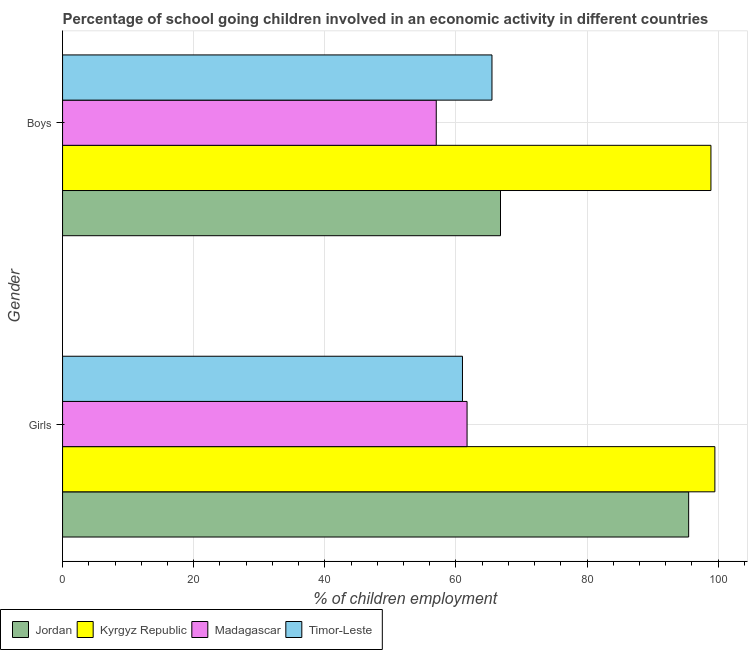Are the number of bars on each tick of the Y-axis equal?
Your answer should be compact. Yes. How many bars are there on the 1st tick from the top?
Ensure brevity in your answer.  4. How many bars are there on the 2nd tick from the bottom?
Your response must be concise. 4. What is the label of the 2nd group of bars from the top?
Offer a very short reply. Girls. Across all countries, what is the maximum percentage of school going girls?
Make the answer very short. 99.5. Across all countries, what is the minimum percentage of school going girls?
Provide a succinct answer. 61. In which country was the percentage of school going boys maximum?
Provide a succinct answer. Kyrgyz Republic. In which country was the percentage of school going boys minimum?
Make the answer very short. Madagascar. What is the total percentage of school going boys in the graph?
Offer a terse response. 288.2. What is the difference between the percentage of school going girls in Timor-Leste and that in Jordan?
Offer a terse response. -34.5. What is the difference between the percentage of school going boys in Kyrgyz Republic and the percentage of school going girls in Madagascar?
Offer a terse response. 37.2. What is the average percentage of school going boys per country?
Keep it short and to the point. 72.05. What is the difference between the percentage of school going girls and percentage of school going boys in Jordan?
Offer a terse response. 28.7. In how many countries, is the percentage of school going girls greater than 4 %?
Ensure brevity in your answer.  4. What is the ratio of the percentage of school going girls in Madagascar to that in Jordan?
Give a very brief answer. 0.65. Is the percentage of school going boys in Timor-Leste less than that in Jordan?
Provide a short and direct response. Yes. In how many countries, is the percentage of school going girls greater than the average percentage of school going girls taken over all countries?
Provide a short and direct response. 2. What does the 2nd bar from the top in Girls represents?
Provide a succinct answer. Madagascar. What does the 4th bar from the bottom in Boys represents?
Make the answer very short. Timor-Leste. How many bars are there?
Offer a very short reply. 8. Are all the bars in the graph horizontal?
Your answer should be compact. Yes. How many countries are there in the graph?
Your answer should be compact. 4. Are the values on the major ticks of X-axis written in scientific E-notation?
Your response must be concise. No. Does the graph contain any zero values?
Make the answer very short. No. How many legend labels are there?
Offer a terse response. 4. How are the legend labels stacked?
Provide a short and direct response. Horizontal. What is the title of the graph?
Your answer should be very brief. Percentage of school going children involved in an economic activity in different countries. Does "Small states" appear as one of the legend labels in the graph?
Your answer should be compact. No. What is the label or title of the X-axis?
Offer a terse response. % of children employment. What is the label or title of the Y-axis?
Provide a short and direct response. Gender. What is the % of children employment of Jordan in Girls?
Provide a succinct answer. 95.5. What is the % of children employment in Kyrgyz Republic in Girls?
Provide a short and direct response. 99.5. What is the % of children employment in Madagascar in Girls?
Offer a very short reply. 61.7. What is the % of children employment of Timor-Leste in Girls?
Ensure brevity in your answer.  61. What is the % of children employment in Jordan in Boys?
Provide a succinct answer. 66.8. What is the % of children employment of Kyrgyz Republic in Boys?
Provide a short and direct response. 98.9. What is the % of children employment in Madagascar in Boys?
Provide a succinct answer. 57. What is the % of children employment of Timor-Leste in Boys?
Offer a terse response. 65.5. Across all Gender, what is the maximum % of children employment in Jordan?
Your response must be concise. 95.5. Across all Gender, what is the maximum % of children employment of Kyrgyz Republic?
Offer a very short reply. 99.5. Across all Gender, what is the maximum % of children employment of Madagascar?
Your answer should be compact. 61.7. Across all Gender, what is the maximum % of children employment in Timor-Leste?
Offer a very short reply. 65.5. Across all Gender, what is the minimum % of children employment in Jordan?
Offer a terse response. 66.8. Across all Gender, what is the minimum % of children employment of Kyrgyz Republic?
Offer a very short reply. 98.9. Across all Gender, what is the minimum % of children employment of Timor-Leste?
Give a very brief answer. 61. What is the total % of children employment of Jordan in the graph?
Provide a short and direct response. 162.3. What is the total % of children employment of Kyrgyz Republic in the graph?
Offer a very short reply. 198.4. What is the total % of children employment in Madagascar in the graph?
Your answer should be compact. 118.7. What is the total % of children employment in Timor-Leste in the graph?
Offer a very short reply. 126.5. What is the difference between the % of children employment of Jordan in Girls and that in Boys?
Your answer should be very brief. 28.7. What is the difference between the % of children employment in Madagascar in Girls and that in Boys?
Offer a terse response. 4.7. What is the difference between the % of children employment in Timor-Leste in Girls and that in Boys?
Offer a terse response. -4.5. What is the difference between the % of children employment of Jordan in Girls and the % of children employment of Madagascar in Boys?
Your answer should be compact. 38.5. What is the difference between the % of children employment in Jordan in Girls and the % of children employment in Timor-Leste in Boys?
Your answer should be very brief. 30. What is the difference between the % of children employment of Kyrgyz Republic in Girls and the % of children employment of Madagascar in Boys?
Ensure brevity in your answer.  42.5. What is the difference between the % of children employment of Madagascar in Girls and the % of children employment of Timor-Leste in Boys?
Provide a short and direct response. -3.8. What is the average % of children employment in Jordan per Gender?
Make the answer very short. 81.15. What is the average % of children employment of Kyrgyz Republic per Gender?
Your response must be concise. 99.2. What is the average % of children employment in Madagascar per Gender?
Your answer should be very brief. 59.35. What is the average % of children employment of Timor-Leste per Gender?
Your answer should be very brief. 63.25. What is the difference between the % of children employment in Jordan and % of children employment in Kyrgyz Republic in Girls?
Your answer should be compact. -4. What is the difference between the % of children employment in Jordan and % of children employment in Madagascar in Girls?
Keep it short and to the point. 33.8. What is the difference between the % of children employment of Jordan and % of children employment of Timor-Leste in Girls?
Provide a succinct answer. 34.5. What is the difference between the % of children employment in Kyrgyz Republic and % of children employment in Madagascar in Girls?
Keep it short and to the point. 37.8. What is the difference between the % of children employment of Kyrgyz Republic and % of children employment of Timor-Leste in Girls?
Your answer should be very brief. 38.5. What is the difference between the % of children employment of Madagascar and % of children employment of Timor-Leste in Girls?
Your answer should be very brief. 0.7. What is the difference between the % of children employment of Jordan and % of children employment of Kyrgyz Republic in Boys?
Provide a short and direct response. -32.1. What is the difference between the % of children employment of Jordan and % of children employment of Madagascar in Boys?
Keep it short and to the point. 9.8. What is the difference between the % of children employment of Kyrgyz Republic and % of children employment of Madagascar in Boys?
Give a very brief answer. 41.9. What is the difference between the % of children employment of Kyrgyz Republic and % of children employment of Timor-Leste in Boys?
Your answer should be compact. 33.4. What is the difference between the % of children employment of Madagascar and % of children employment of Timor-Leste in Boys?
Give a very brief answer. -8.5. What is the ratio of the % of children employment of Jordan in Girls to that in Boys?
Your answer should be compact. 1.43. What is the ratio of the % of children employment of Madagascar in Girls to that in Boys?
Make the answer very short. 1.08. What is the ratio of the % of children employment in Timor-Leste in Girls to that in Boys?
Make the answer very short. 0.93. What is the difference between the highest and the second highest % of children employment in Jordan?
Make the answer very short. 28.7. What is the difference between the highest and the second highest % of children employment of Timor-Leste?
Provide a succinct answer. 4.5. What is the difference between the highest and the lowest % of children employment in Jordan?
Provide a short and direct response. 28.7. What is the difference between the highest and the lowest % of children employment in Madagascar?
Offer a terse response. 4.7. What is the difference between the highest and the lowest % of children employment of Timor-Leste?
Give a very brief answer. 4.5. 